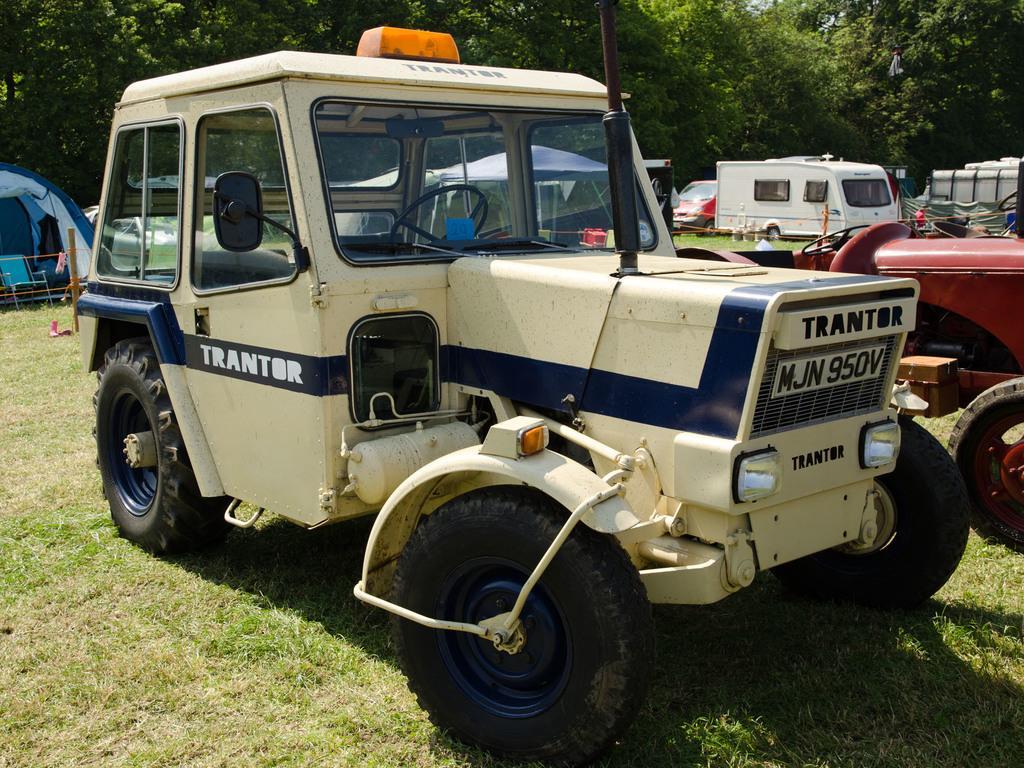Could you give a brief overview of what you see in this image? In the center of the image we can see some vehicles, barricades, chair, tent. In the background of the image we can see the trees. At the bottom of the image we can see the ground. 